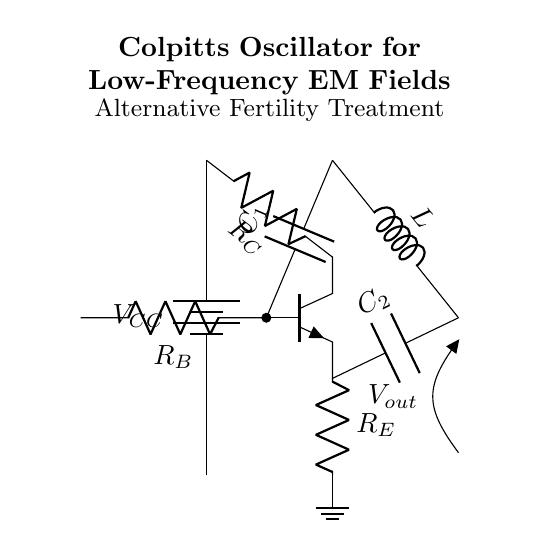What type of electronic circuit is shown? The circuit is a Colpitts oscillator, which is identified by the specific arrangement of a transistor and associated components. The presence of a capacitor in the feedback path and the utilization of an inductor also indicate that it is an oscillator circuit.
Answer: Colpitts oscillator What are the components present in this circuit? The components include a battery, a transistor, three resistors, two capacitors, and an inductor. Each component serves a specific role in the functioning of the oscillator.
Answer: Battery, transistor, resistors, capacitors, inductor What is the purpose of the inductor in this circuit? The inductor is used in conjunction with the capacitors to determine the frequency of oscillation. Its role is to provide reactance, which is necessary for the oscillator to produce a stable output frequency.
Answer: Frequency determination What is the output voltage labeled as in the circuit? The output voltage is labeled as V out, which indicates the point where the oscillation signal is derived from the circuit for external use or measurement.
Answer: V out How many capacitors are there in the Colpitts oscillator circuit? There are two capacitors in the circuit, which are essential for creating the feedback necessary for oscillation. Each capacitor is part of the LC tank circuit that sustains the oscillation.
Answer: Two What role do the resistors play in this circuit? The resistors in the circuit set biasing conditions for the transistor and affect the gain of the circuit. They help stabilize the operation of the oscillator.
Answer: Biasing and stabilization What is the potential difference supplied by the battery? The potential difference supplied by the battery is labeled as V CC, which indicates the power supply for the oscillator circuit, essential for its operation.
Answer: V CC 